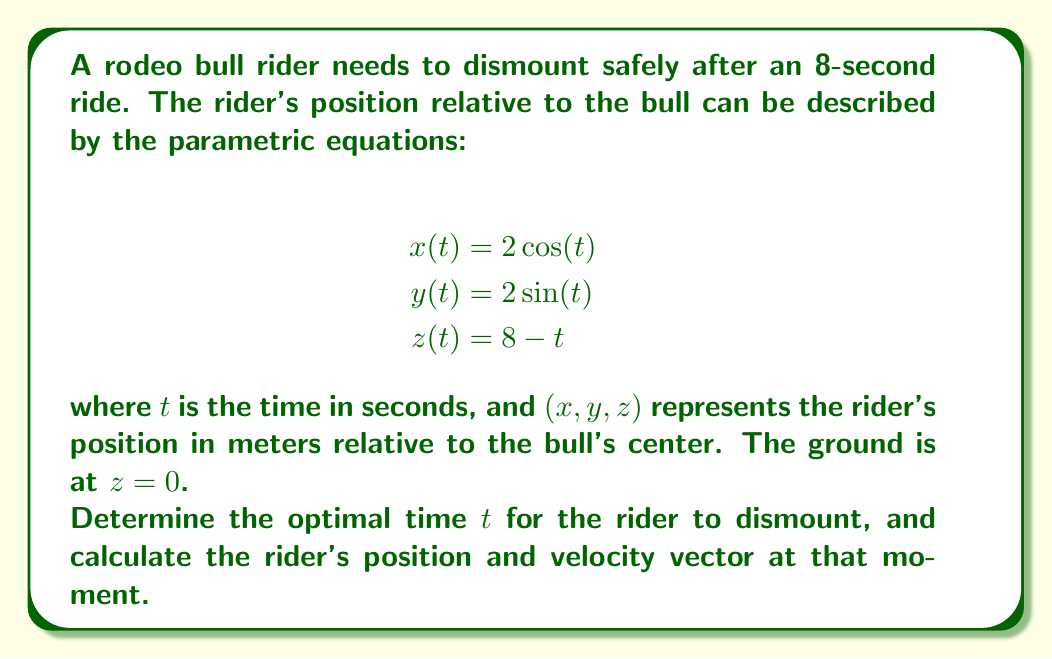What is the answer to this math problem? To solve this problem, we need to follow these steps:

1) The optimal time to dismount is when the rider is closest to the ground while still having some forward momentum. This occurs when $z=0$.

2) Solve the equation $z(t) = 0$:
   $$8 - t = 0$$
   $$t = 8$$

3) Calculate the position at $t=8$:
   $$x(8) = 2\cos(8) \approx 1.146$$
   $$y(8) = 2\sin(8) \approx -1.675$$
   $$z(8) = 8 - 8 = 0$$

4) To find the velocity vector, we need to differentiate the position functions:
   $$\frac{dx}{dt} = -2\sin(t)$$
   $$\frac{dy}{dt} = 2\cos(t)$$
   $$\frac{dz}{dt} = -1$$

5) Calculate the velocity at $t=8$:
   $$\frac{dx}{dt}(8) = -2\sin(8) \approx 1.675$$
   $$\frac{dy}{dt}(8) = 2\cos(8) \approx 1.146$$
   $$\frac{dz}{dt}(8) = -1$$

6) The velocity vector at $t=8$ is:
   $$\vec{v}(8) = \langle 1.675, 1.146, -1 \rangle$$
Answer: The optimal time to dismount is $t=8$ seconds. At this time, the rider's position is approximately $(1.146, -1.675, 0)$ meters relative to the bull's center, and the velocity vector is $\langle 1.675, 1.146, -1 \rangle$ meters per second. 